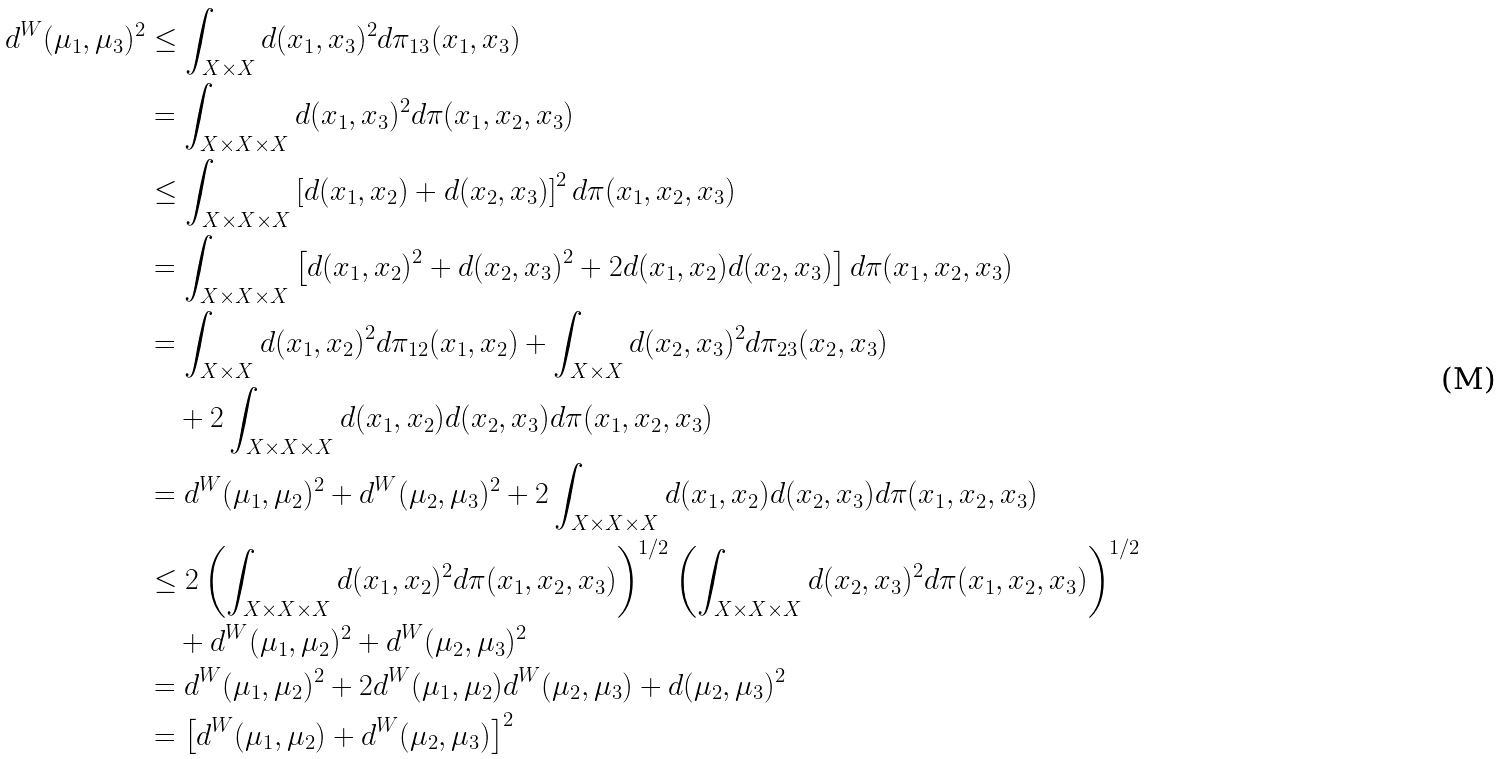<formula> <loc_0><loc_0><loc_500><loc_500>d ^ { W } ( \mu _ { 1 } , \mu _ { 3 } ) ^ { 2 } & \leq \int _ { X \times X } d ( x _ { 1 } , x _ { 3 } ) ^ { 2 } d \pi _ { 1 3 } ( x _ { 1 } , x _ { 3 } ) \\ & = \int _ { X \times X \times X } d ( x _ { 1 } , x _ { 3 } ) ^ { 2 } d \pi ( x _ { 1 } , x _ { 2 } , x _ { 3 } ) \\ & \leq \int _ { X \times X \times X } \left [ d ( x _ { 1 } , x _ { 2 } ) + d ( x _ { 2 } , x _ { 3 } ) \right ] ^ { 2 } d \pi ( x _ { 1 } , x _ { 2 } , x _ { 3 } ) \\ & = \int _ { X \times X \times X } \left [ d ( x _ { 1 } , x _ { 2 } ) ^ { 2 } + d ( x _ { 2 } , x _ { 3 } ) ^ { 2 } + 2 d ( x _ { 1 } , x _ { 2 } ) d ( x _ { 2 } , x _ { 3 } ) \right ] d \pi ( x _ { 1 } , x _ { 2 } , x _ { 3 } ) \\ & = \int _ { X \times X } d ( x _ { 1 } , x _ { 2 } ) ^ { 2 } d \pi _ { 1 2 } ( x _ { 1 } , x _ { 2 } ) + \int _ { X \times X } d ( x _ { 2 } , x _ { 3 } ) ^ { 2 } d \pi _ { 2 3 } ( x _ { 2 } , x _ { 3 } ) \\ & \quad + 2 \int _ { X \times X \times X } d ( x _ { 1 } , x _ { 2 } ) d ( x _ { 2 } , x _ { 3 } ) d \pi ( x _ { 1 } , x _ { 2 } , x _ { 3 } ) \\ & = d ^ { W } ( \mu _ { 1 } , \mu _ { 2 } ) ^ { 2 } + d ^ { W } ( \mu _ { 2 } , \mu _ { 3 } ) ^ { 2 } + 2 \int _ { X \times X \times X } d ( x _ { 1 } , x _ { 2 } ) d ( x _ { 2 } , x _ { 3 } ) d \pi ( x _ { 1 } , x _ { 2 } , x _ { 3 } ) \\ & \leq 2 \left ( \int _ { X \times X \times X } d ( x _ { 1 } , x _ { 2 } ) ^ { 2 } d \pi ( x _ { 1 } , x _ { 2 } , x _ { 3 } ) \right ) ^ { 1 / 2 } \left ( \int _ { X \times X \times X } d ( x _ { 2 } , x _ { 3 } ) ^ { 2 } d \pi ( x _ { 1 } , x _ { 2 } , x _ { 3 } ) \right ) ^ { 1 / 2 } \\ & \quad + d ^ { W } ( \mu _ { 1 } , \mu _ { 2 } ) ^ { 2 } + d ^ { W } ( \mu _ { 2 } , \mu _ { 3 } ) ^ { 2 } \\ & = d ^ { W } ( \mu _ { 1 } , \mu _ { 2 } ) ^ { 2 } + 2 d ^ { W } ( \mu _ { 1 } , \mu _ { 2 } ) d ^ { W } ( \mu _ { 2 } , \mu _ { 3 } ) + d ( \mu _ { 2 } , \mu _ { 3 } ) ^ { 2 } \\ & = \left [ d ^ { W } ( \mu _ { 1 } , \mu _ { 2 } ) + d ^ { W } ( \mu _ { 2 } , \mu _ { 3 } ) \right ] ^ { 2 }</formula> 